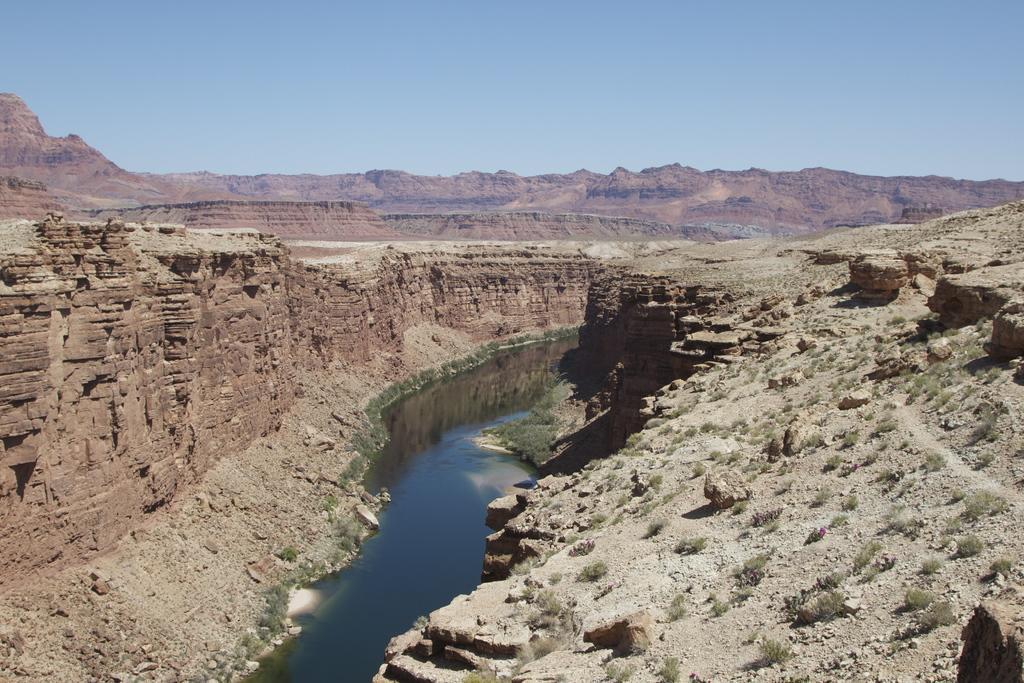Could you give a brief overview of what you see in this image? In this image I can see the ground, some grass on the ground, few rocks and the water. In the background I can see a mountain and the sky. 